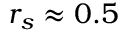<formula> <loc_0><loc_0><loc_500><loc_500>r _ { s } \approx 0 . 5</formula> 